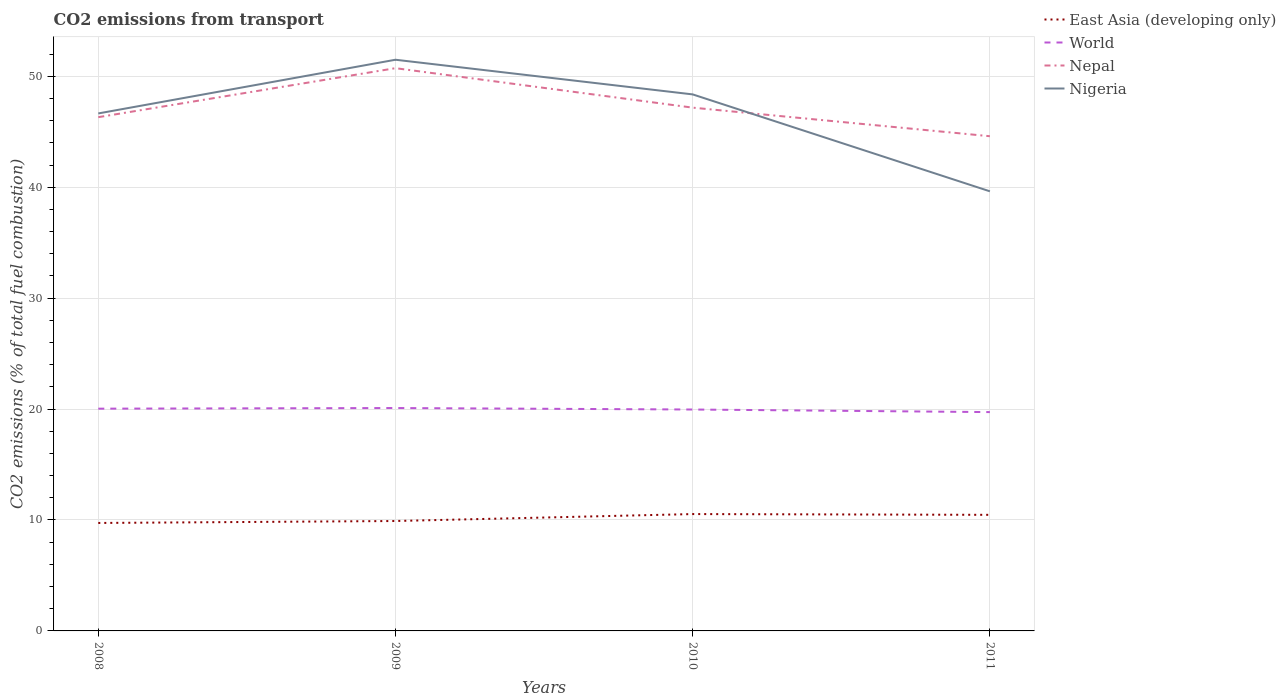Is the number of lines equal to the number of legend labels?
Your answer should be very brief. Yes. Across all years, what is the maximum total CO2 emitted in Nepal?
Offer a very short reply. 44.6. What is the total total CO2 emitted in East Asia (developing only) in the graph?
Ensure brevity in your answer.  -0.8. What is the difference between the highest and the second highest total CO2 emitted in East Asia (developing only)?
Your response must be concise. 0.8. What is the difference between the highest and the lowest total CO2 emitted in East Asia (developing only)?
Give a very brief answer. 2. Is the total CO2 emitted in East Asia (developing only) strictly greater than the total CO2 emitted in World over the years?
Provide a short and direct response. Yes. How many years are there in the graph?
Your response must be concise. 4. Does the graph contain any zero values?
Offer a very short reply. No. Does the graph contain grids?
Offer a terse response. Yes. Where does the legend appear in the graph?
Keep it short and to the point. Top right. What is the title of the graph?
Offer a terse response. CO2 emissions from transport. Does "Zimbabwe" appear as one of the legend labels in the graph?
Your answer should be compact. No. What is the label or title of the X-axis?
Keep it short and to the point. Years. What is the label or title of the Y-axis?
Provide a short and direct response. CO2 emissions (% of total fuel combustion). What is the CO2 emissions (% of total fuel combustion) in East Asia (developing only) in 2008?
Offer a very short reply. 9.73. What is the CO2 emissions (% of total fuel combustion) of World in 2008?
Keep it short and to the point. 20.04. What is the CO2 emissions (% of total fuel combustion) of Nepal in 2008?
Offer a very short reply. 46.32. What is the CO2 emissions (% of total fuel combustion) of Nigeria in 2008?
Your response must be concise. 46.65. What is the CO2 emissions (% of total fuel combustion) in East Asia (developing only) in 2009?
Your response must be concise. 9.91. What is the CO2 emissions (% of total fuel combustion) in World in 2009?
Provide a short and direct response. 20.09. What is the CO2 emissions (% of total fuel combustion) in Nepal in 2009?
Provide a short and direct response. 50.73. What is the CO2 emissions (% of total fuel combustion) of Nigeria in 2009?
Keep it short and to the point. 51.49. What is the CO2 emissions (% of total fuel combustion) in East Asia (developing only) in 2010?
Your answer should be very brief. 10.54. What is the CO2 emissions (% of total fuel combustion) in World in 2010?
Offer a terse response. 19.96. What is the CO2 emissions (% of total fuel combustion) of Nepal in 2010?
Offer a terse response. 47.17. What is the CO2 emissions (% of total fuel combustion) in Nigeria in 2010?
Your answer should be very brief. 48.37. What is the CO2 emissions (% of total fuel combustion) of East Asia (developing only) in 2011?
Provide a short and direct response. 10.47. What is the CO2 emissions (% of total fuel combustion) in World in 2011?
Provide a succinct answer. 19.73. What is the CO2 emissions (% of total fuel combustion) of Nepal in 2011?
Ensure brevity in your answer.  44.6. What is the CO2 emissions (% of total fuel combustion) in Nigeria in 2011?
Your answer should be very brief. 39.63. Across all years, what is the maximum CO2 emissions (% of total fuel combustion) in East Asia (developing only)?
Make the answer very short. 10.54. Across all years, what is the maximum CO2 emissions (% of total fuel combustion) of World?
Offer a terse response. 20.09. Across all years, what is the maximum CO2 emissions (% of total fuel combustion) of Nepal?
Your answer should be very brief. 50.73. Across all years, what is the maximum CO2 emissions (% of total fuel combustion) of Nigeria?
Ensure brevity in your answer.  51.49. Across all years, what is the minimum CO2 emissions (% of total fuel combustion) in East Asia (developing only)?
Offer a very short reply. 9.73. Across all years, what is the minimum CO2 emissions (% of total fuel combustion) of World?
Make the answer very short. 19.73. Across all years, what is the minimum CO2 emissions (% of total fuel combustion) in Nepal?
Offer a very short reply. 44.6. Across all years, what is the minimum CO2 emissions (% of total fuel combustion) in Nigeria?
Offer a terse response. 39.63. What is the total CO2 emissions (% of total fuel combustion) of East Asia (developing only) in the graph?
Give a very brief answer. 40.64. What is the total CO2 emissions (% of total fuel combustion) of World in the graph?
Provide a short and direct response. 79.82. What is the total CO2 emissions (% of total fuel combustion) of Nepal in the graph?
Offer a very short reply. 188.82. What is the total CO2 emissions (% of total fuel combustion) of Nigeria in the graph?
Give a very brief answer. 186.15. What is the difference between the CO2 emissions (% of total fuel combustion) in East Asia (developing only) in 2008 and that in 2009?
Provide a short and direct response. -0.18. What is the difference between the CO2 emissions (% of total fuel combustion) of World in 2008 and that in 2009?
Offer a very short reply. -0.06. What is the difference between the CO2 emissions (% of total fuel combustion) of Nepal in 2008 and that in 2009?
Provide a short and direct response. -4.42. What is the difference between the CO2 emissions (% of total fuel combustion) of Nigeria in 2008 and that in 2009?
Make the answer very short. -4.84. What is the difference between the CO2 emissions (% of total fuel combustion) in East Asia (developing only) in 2008 and that in 2010?
Provide a succinct answer. -0.8. What is the difference between the CO2 emissions (% of total fuel combustion) in World in 2008 and that in 2010?
Your response must be concise. 0.08. What is the difference between the CO2 emissions (% of total fuel combustion) in Nepal in 2008 and that in 2010?
Keep it short and to the point. -0.86. What is the difference between the CO2 emissions (% of total fuel combustion) of Nigeria in 2008 and that in 2010?
Offer a very short reply. -1.72. What is the difference between the CO2 emissions (% of total fuel combustion) in East Asia (developing only) in 2008 and that in 2011?
Your answer should be very brief. -0.73. What is the difference between the CO2 emissions (% of total fuel combustion) of World in 2008 and that in 2011?
Keep it short and to the point. 0.31. What is the difference between the CO2 emissions (% of total fuel combustion) of Nepal in 2008 and that in 2011?
Your answer should be very brief. 1.72. What is the difference between the CO2 emissions (% of total fuel combustion) in Nigeria in 2008 and that in 2011?
Provide a short and direct response. 7.02. What is the difference between the CO2 emissions (% of total fuel combustion) in East Asia (developing only) in 2009 and that in 2010?
Offer a very short reply. -0.63. What is the difference between the CO2 emissions (% of total fuel combustion) in World in 2009 and that in 2010?
Give a very brief answer. 0.13. What is the difference between the CO2 emissions (% of total fuel combustion) of Nepal in 2009 and that in 2010?
Keep it short and to the point. 3.56. What is the difference between the CO2 emissions (% of total fuel combustion) of Nigeria in 2009 and that in 2010?
Give a very brief answer. 3.13. What is the difference between the CO2 emissions (% of total fuel combustion) of East Asia (developing only) in 2009 and that in 2011?
Offer a very short reply. -0.56. What is the difference between the CO2 emissions (% of total fuel combustion) of World in 2009 and that in 2011?
Your response must be concise. 0.37. What is the difference between the CO2 emissions (% of total fuel combustion) of Nepal in 2009 and that in 2011?
Offer a very short reply. 6.14. What is the difference between the CO2 emissions (% of total fuel combustion) of Nigeria in 2009 and that in 2011?
Give a very brief answer. 11.86. What is the difference between the CO2 emissions (% of total fuel combustion) of East Asia (developing only) in 2010 and that in 2011?
Keep it short and to the point. 0.07. What is the difference between the CO2 emissions (% of total fuel combustion) of World in 2010 and that in 2011?
Your answer should be very brief. 0.23. What is the difference between the CO2 emissions (% of total fuel combustion) of Nepal in 2010 and that in 2011?
Provide a succinct answer. 2.58. What is the difference between the CO2 emissions (% of total fuel combustion) of Nigeria in 2010 and that in 2011?
Ensure brevity in your answer.  8.74. What is the difference between the CO2 emissions (% of total fuel combustion) in East Asia (developing only) in 2008 and the CO2 emissions (% of total fuel combustion) in World in 2009?
Make the answer very short. -10.36. What is the difference between the CO2 emissions (% of total fuel combustion) in East Asia (developing only) in 2008 and the CO2 emissions (% of total fuel combustion) in Nepal in 2009?
Your response must be concise. -41. What is the difference between the CO2 emissions (% of total fuel combustion) of East Asia (developing only) in 2008 and the CO2 emissions (% of total fuel combustion) of Nigeria in 2009?
Provide a succinct answer. -41.76. What is the difference between the CO2 emissions (% of total fuel combustion) in World in 2008 and the CO2 emissions (% of total fuel combustion) in Nepal in 2009?
Offer a very short reply. -30.7. What is the difference between the CO2 emissions (% of total fuel combustion) in World in 2008 and the CO2 emissions (% of total fuel combustion) in Nigeria in 2009?
Offer a terse response. -31.46. What is the difference between the CO2 emissions (% of total fuel combustion) of Nepal in 2008 and the CO2 emissions (% of total fuel combustion) of Nigeria in 2009?
Your answer should be very brief. -5.18. What is the difference between the CO2 emissions (% of total fuel combustion) of East Asia (developing only) in 2008 and the CO2 emissions (% of total fuel combustion) of World in 2010?
Ensure brevity in your answer.  -10.23. What is the difference between the CO2 emissions (% of total fuel combustion) in East Asia (developing only) in 2008 and the CO2 emissions (% of total fuel combustion) in Nepal in 2010?
Your answer should be very brief. -37.44. What is the difference between the CO2 emissions (% of total fuel combustion) of East Asia (developing only) in 2008 and the CO2 emissions (% of total fuel combustion) of Nigeria in 2010?
Your answer should be very brief. -38.64. What is the difference between the CO2 emissions (% of total fuel combustion) in World in 2008 and the CO2 emissions (% of total fuel combustion) in Nepal in 2010?
Offer a very short reply. -27.14. What is the difference between the CO2 emissions (% of total fuel combustion) in World in 2008 and the CO2 emissions (% of total fuel combustion) in Nigeria in 2010?
Provide a succinct answer. -28.33. What is the difference between the CO2 emissions (% of total fuel combustion) in Nepal in 2008 and the CO2 emissions (% of total fuel combustion) in Nigeria in 2010?
Provide a succinct answer. -2.05. What is the difference between the CO2 emissions (% of total fuel combustion) in East Asia (developing only) in 2008 and the CO2 emissions (% of total fuel combustion) in World in 2011?
Give a very brief answer. -9.99. What is the difference between the CO2 emissions (% of total fuel combustion) of East Asia (developing only) in 2008 and the CO2 emissions (% of total fuel combustion) of Nepal in 2011?
Your answer should be compact. -34.86. What is the difference between the CO2 emissions (% of total fuel combustion) in East Asia (developing only) in 2008 and the CO2 emissions (% of total fuel combustion) in Nigeria in 2011?
Make the answer very short. -29.9. What is the difference between the CO2 emissions (% of total fuel combustion) of World in 2008 and the CO2 emissions (% of total fuel combustion) of Nepal in 2011?
Offer a very short reply. -24.56. What is the difference between the CO2 emissions (% of total fuel combustion) of World in 2008 and the CO2 emissions (% of total fuel combustion) of Nigeria in 2011?
Your answer should be very brief. -19.59. What is the difference between the CO2 emissions (% of total fuel combustion) of Nepal in 2008 and the CO2 emissions (% of total fuel combustion) of Nigeria in 2011?
Keep it short and to the point. 6.68. What is the difference between the CO2 emissions (% of total fuel combustion) of East Asia (developing only) in 2009 and the CO2 emissions (% of total fuel combustion) of World in 2010?
Give a very brief answer. -10.05. What is the difference between the CO2 emissions (% of total fuel combustion) in East Asia (developing only) in 2009 and the CO2 emissions (% of total fuel combustion) in Nepal in 2010?
Make the answer very short. -37.27. What is the difference between the CO2 emissions (% of total fuel combustion) in East Asia (developing only) in 2009 and the CO2 emissions (% of total fuel combustion) in Nigeria in 2010?
Your answer should be compact. -38.46. What is the difference between the CO2 emissions (% of total fuel combustion) of World in 2009 and the CO2 emissions (% of total fuel combustion) of Nepal in 2010?
Provide a succinct answer. -27.08. What is the difference between the CO2 emissions (% of total fuel combustion) in World in 2009 and the CO2 emissions (% of total fuel combustion) in Nigeria in 2010?
Provide a short and direct response. -28.27. What is the difference between the CO2 emissions (% of total fuel combustion) in Nepal in 2009 and the CO2 emissions (% of total fuel combustion) in Nigeria in 2010?
Make the answer very short. 2.36. What is the difference between the CO2 emissions (% of total fuel combustion) in East Asia (developing only) in 2009 and the CO2 emissions (% of total fuel combustion) in World in 2011?
Provide a succinct answer. -9.82. What is the difference between the CO2 emissions (% of total fuel combustion) of East Asia (developing only) in 2009 and the CO2 emissions (% of total fuel combustion) of Nepal in 2011?
Offer a very short reply. -34.69. What is the difference between the CO2 emissions (% of total fuel combustion) in East Asia (developing only) in 2009 and the CO2 emissions (% of total fuel combustion) in Nigeria in 2011?
Ensure brevity in your answer.  -29.72. What is the difference between the CO2 emissions (% of total fuel combustion) in World in 2009 and the CO2 emissions (% of total fuel combustion) in Nepal in 2011?
Your answer should be very brief. -24.5. What is the difference between the CO2 emissions (% of total fuel combustion) of World in 2009 and the CO2 emissions (% of total fuel combustion) of Nigeria in 2011?
Your answer should be compact. -19.54. What is the difference between the CO2 emissions (% of total fuel combustion) of Nepal in 2009 and the CO2 emissions (% of total fuel combustion) of Nigeria in 2011?
Give a very brief answer. 11.1. What is the difference between the CO2 emissions (% of total fuel combustion) in East Asia (developing only) in 2010 and the CO2 emissions (% of total fuel combustion) in World in 2011?
Make the answer very short. -9.19. What is the difference between the CO2 emissions (% of total fuel combustion) of East Asia (developing only) in 2010 and the CO2 emissions (% of total fuel combustion) of Nepal in 2011?
Give a very brief answer. -34.06. What is the difference between the CO2 emissions (% of total fuel combustion) in East Asia (developing only) in 2010 and the CO2 emissions (% of total fuel combustion) in Nigeria in 2011?
Give a very brief answer. -29.1. What is the difference between the CO2 emissions (% of total fuel combustion) in World in 2010 and the CO2 emissions (% of total fuel combustion) in Nepal in 2011?
Provide a succinct answer. -24.64. What is the difference between the CO2 emissions (% of total fuel combustion) of World in 2010 and the CO2 emissions (% of total fuel combustion) of Nigeria in 2011?
Your response must be concise. -19.67. What is the difference between the CO2 emissions (% of total fuel combustion) of Nepal in 2010 and the CO2 emissions (% of total fuel combustion) of Nigeria in 2011?
Give a very brief answer. 7.54. What is the average CO2 emissions (% of total fuel combustion) in East Asia (developing only) per year?
Give a very brief answer. 10.16. What is the average CO2 emissions (% of total fuel combustion) of World per year?
Ensure brevity in your answer.  19.95. What is the average CO2 emissions (% of total fuel combustion) of Nepal per year?
Make the answer very short. 47.21. What is the average CO2 emissions (% of total fuel combustion) in Nigeria per year?
Provide a short and direct response. 46.54. In the year 2008, what is the difference between the CO2 emissions (% of total fuel combustion) of East Asia (developing only) and CO2 emissions (% of total fuel combustion) of World?
Provide a succinct answer. -10.3. In the year 2008, what is the difference between the CO2 emissions (% of total fuel combustion) in East Asia (developing only) and CO2 emissions (% of total fuel combustion) in Nepal?
Your answer should be compact. -36.58. In the year 2008, what is the difference between the CO2 emissions (% of total fuel combustion) in East Asia (developing only) and CO2 emissions (% of total fuel combustion) in Nigeria?
Make the answer very short. -36.92. In the year 2008, what is the difference between the CO2 emissions (% of total fuel combustion) in World and CO2 emissions (% of total fuel combustion) in Nepal?
Offer a terse response. -26.28. In the year 2008, what is the difference between the CO2 emissions (% of total fuel combustion) in World and CO2 emissions (% of total fuel combustion) in Nigeria?
Provide a short and direct response. -26.62. In the year 2008, what is the difference between the CO2 emissions (% of total fuel combustion) of Nepal and CO2 emissions (% of total fuel combustion) of Nigeria?
Provide a short and direct response. -0.34. In the year 2009, what is the difference between the CO2 emissions (% of total fuel combustion) in East Asia (developing only) and CO2 emissions (% of total fuel combustion) in World?
Provide a succinct answer. -10.19. In the year 2009, what is the difference between the CO2 emissions (% of total fuel combustion) of East Asia (developing only) and CO2 emissions (% of total fuel combustion) of Nepal?
Provide a succinct answer. -40.82. In the year 2009, what is the difference between the CO2 emissions (% of total fuel combustion) in East Asia (developing only) and CO2 emissions (% of total fuel combustion) in Nigeria?
Offer a very short reply. -41.58. In the year 2009, what is the difference between the CO2 emissions (% of total fuel combustion) in World and CO2 emissions (% of total fuel combustion) in Nepal?
Provide a short and direct response. -30.64. In the year 2009, what is the difference between the CO2 emissions (% of total fuel combustion) of World and CO2 emissions (% of total fuel combustion) of Nigeria?
Offer a very short reply. -31.4. In the year 2009, what is the difference between the CO2 emissions (% of total fuel combustion) in Nepal and CO2 emissions (% of total fuel combustion) in Nigeria?
Ensure brevity in your answer.  -0.76. In the year 2010, what is the difference between the CO2 emissions (% of total fuel combustion) of East Asia (developing only) and CO2 emissions (% of total fuel combustion) of World?
Provide a short and direct response. -9.43. In the year 2010, what is the difference between the CO2 emissions (% of total fuel combustion) of East Asia (developing only) and CO2 emissions (% of total fuel combustion) of Nepal?
Offer a very short reply. -36.64. In the year 2010, what is the difference between the CO2 emissions (% of total fuel combustion) of East Asia (developing only) and CO2 emissions (% of total fuel combustion) of Nigeria?
Offer a terse response. -37.83. In the year 2010, what is the difference between the CO2 emissions (% of total fuel combustion) in World and CO2 emissions (% of total fuel combustion) in Nepal?
Make the answer very short. -27.21. In the year 2010, what is the difference between the CO2 emissions (% of total fuel combustion) in World and CO2 emissions (% of total fuel combustion) in Nigeria?
Provide a short and direct response. -28.41. In the year 2010, what is the difference between the CO2 emissions (% of total fuel combustion) in Nepal and CO2 emissions (% of total fuel combustion) in Nigeria?
Keep it short and to the point. -1.19. In the year 2011, what is the difference between the CO2 emissions (% of total fuel combustion) of East Asia (developing only) and CO2 emissions (% of total fuel combustion) of World?
Your response must be concise. -9.26. In the year 2011, what is the difference between the CO2 emissions (% of total fuel combustion) in East Asia (developing only) and CO2 emissions (% of total fuel combustion) in Nepal?
Your answer should be compact. -34.13. In the year 2011, what is the difference between the CO2 emissions (% of total fuel combustion) in East Asia (developing only) and CO2 emissions (% of total fuel combustion) in Nigeria?
Give a very brief answer. -29.17. In the year 2011, what is the difference between the CO2 emissions (% of total fuel combustion) in World and CO2 emissions (% of total fuel combustion) in Nepal?
Offer a terse response. -24.87. In the year 2011, what is the difference between the CO2 emissions (% of total fuel combustion) of World and CO2 emissions (% of total fuel combustion) of Nigeria?
Give a very brief answer. -19.9. In the year 2011, what is the difference between the CO2 emissions (% of total fuel combustion) in Nepal and CO2 emissions (% of total fuel combustion) in Nigeria?
Offer a terse response. 4.97. What is the ratio of the CO2 emissions (% of total fuel combustion) of East Asia (developing only) in 2008 to that in 2009?
Make the answer very short. 0.98. What is the ratio of the CO2 emissions (% of total fuel combustion) of Nepal in 2008 to that in 2009?
Offer a very short reply. 0.91. What is the ratio of the CO2 emissions (% of total fuel combustion) in Nigeria in 2008 to that in 2009?
Your answer should be compact. 0.91. What is the ratio of the CO2 emissions (% of total fuel combustion) of East Asia (developing only) in 2008 to that in 2010?
Ensure brevity in your answer.  0.92. What is the ratio of the CO2 emissions (% of total fuel combustion) in World in 2008 to that in 2010?
Your response must be concise. 1. What is the ratio of the CO2 emissions (% of total fuel combustion) in Nepal in 2008 to that in 2010?
Your response must be concise. 0.98. What is the ratio of the CO2 emissions (% of total fuel combustion) in Nigeria in 2008 to that in 2010?
Provide a succinct answer. 0.96. What is the ratio of the CO2 emissions (% of total fuel combustion) in World in 2008 to that in 2011?
Make the answer very short. 1.02. What is the ratio of the CO2 emissions (% of total fuel combustion) in Nigeria in 2008 to that in 2011?
Offer a very short reply. 1.18. What is the ratio of the CO2 emissions (% of total fuel combustion) in East Asia (developing only) in 2009 to that in 2010?
Provide a succinct answer. 0.94. What is the ratio of the CO2 emissions (% of total fuel combustion) in World in 2009 to that in 2010?
Keep it short and to the point. 1.01. What is the ratio of the CO2 emissions (% of total fuel combustion) in Nepal in 2009 to that in 2010?
Keep it short and to the point. 1.08. What is the ratio of the CO2 emissions (% of total fuel combustion) of Nigeria in 2009 to that in 2010?
Make the answer very short. 1.06. What is the ratio of the CO2 emissions (% of total fuel combustion) in East Asia (developing only) in 2009 to that in 2011?
Keep it short and to the point. 0.95. What is the ratio of the CO2 emissions (% of total fuel combustion) of World in 2009 to that in 2011?
Provide a succinct answer. 1.02. What is the ratio of the CO2 emissions (% of total fuel combustion) of Nepal in 2009 to that in 2011?
Make the answer very short. 1.14. What is the ratio of the CO2 emissions (% of total fuel combustion) of Nigeria in 2009 to that in 2011?
Provide a short and direct response. 1.3. What is the ratio of the CO2 emissions (% of total fuel combustion) of East Asia (developing only) in 2010 to that in 2011?
Offer a terse response. 1.01. What is the ratio of the CO2 emissions (% of total fuel combustion) in World in 2010 to that in 2011?
Your response must be concise. 1.01. What is the ratio of the CO2 emissions (% of total fuel combustion) in Nepal in 2010 to that in 2011?
Offer a terse response. 1.06. What is the ratio of the CO2 emissions (% of total fuel combustion) of Nigeria in 2010 to that in 2011?
Your answer should be compact. 1.22. What is the difference between the highest and the second highest CO2 emissions (% of total fuel combustion) in East Asia (developing only)?
Provide a succinct answer. 0.07. What is the difference between the highest and the second highest CO2 emissions (% of total fuel combustion) in World?
Your answer should be very brief. 0.06. What is the difference between the highest and the second highest CO2 emissions (% of total fuel combustion) of Nepal?
Ensure brevity in your answer.  3.56. What is the difference between the highest and the second highest CO2 emissions (% of total fuel combustion) of Nigeria?
Offer a very short reply. 3.13. What is the difference between the highest and the lowest CO2 emissions (% of total fuel combustion) of East Asia (developing only)?
Your response must be concise. 0.8. What is the difference between the highest and the lowest CO2 emissions (% of total fuel combustion) in World?
Your answer should be very brief. 0.37. What is the difference between the highest and the lowest CO2 emissions (% of total fuel combustion) in Nepal?
Keep it short and to the point. 6.14. What is the difference between the highest and the lowest CO2 emissions (% of total fuel combustion) of Nigeria?
Offer a very short reply. 11.86. 